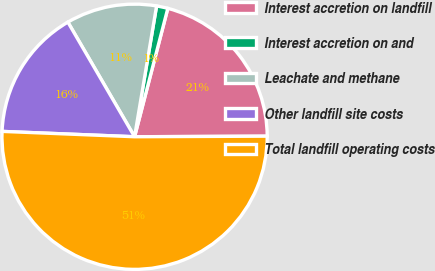Convert chart to OTSL. <chart><loc_0><loc_0><loc_500><loc_500><pie_chart><fcel>Interest accretion on landfill<fcel>Interest accretion on and<fcel>Leachate and methane<fcel>Other landfill site costs<fcel>Total landfill operating costs<nl><fcel>20.9%<fcel>1.38%<fcel>11.04%<fcel>15.97%<fcel>50.71%<nl></chart> 